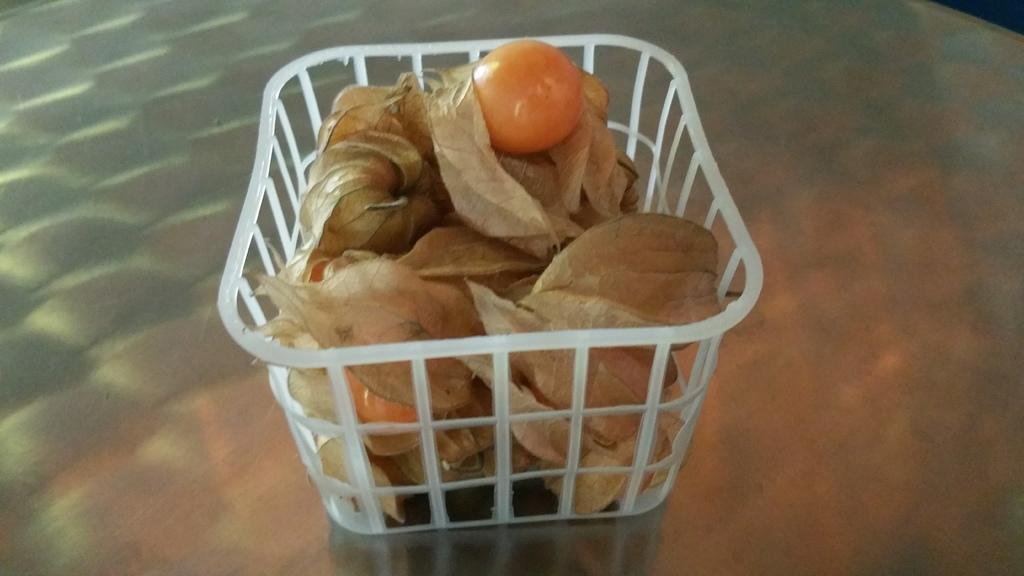What object is present in the image that can hold items? There is a basket in the image. What type of items can be found inside the basket? The basket contains fruits. Are there any additional items in the basket related to the fruits? Yes, there are peels in the basket. How does the basket compare to a wine bottle in terms of size? The image does not include a wine bottle, so it is not possible to make a comparison between the basket and a wine bottle in terms of size. 